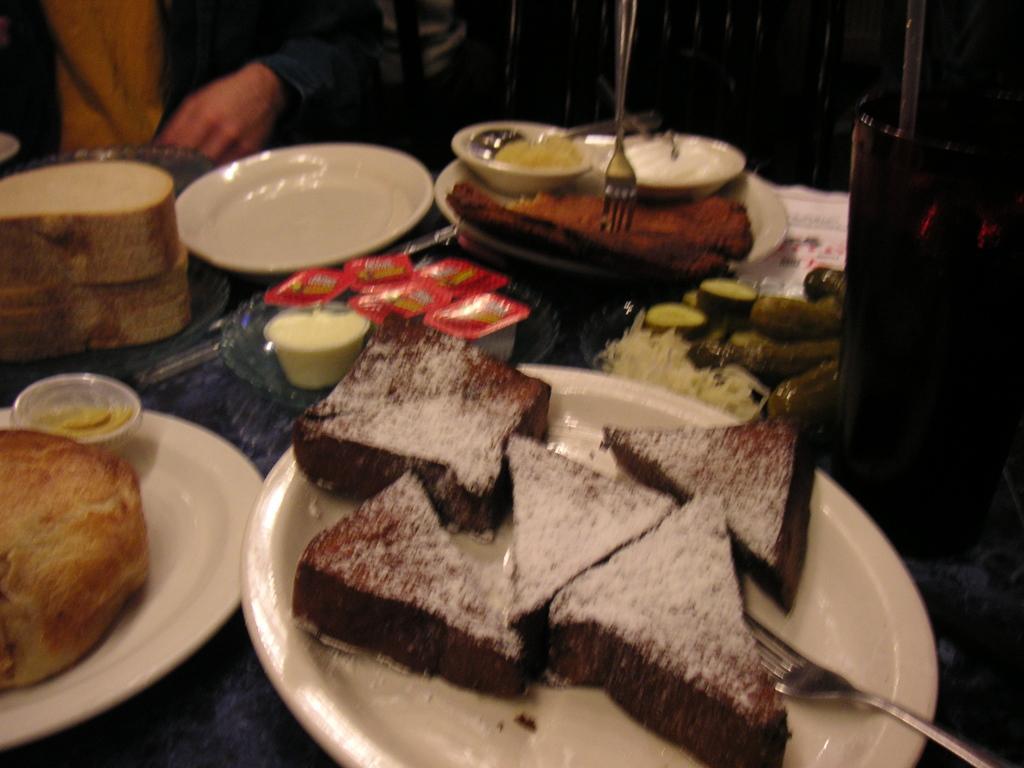Please provide a concise description of this image. In the picture there are some food items kept on a table like desserts, creams, cucumber, breads and also some plates and forks and there is a person sitting in front of the table. 